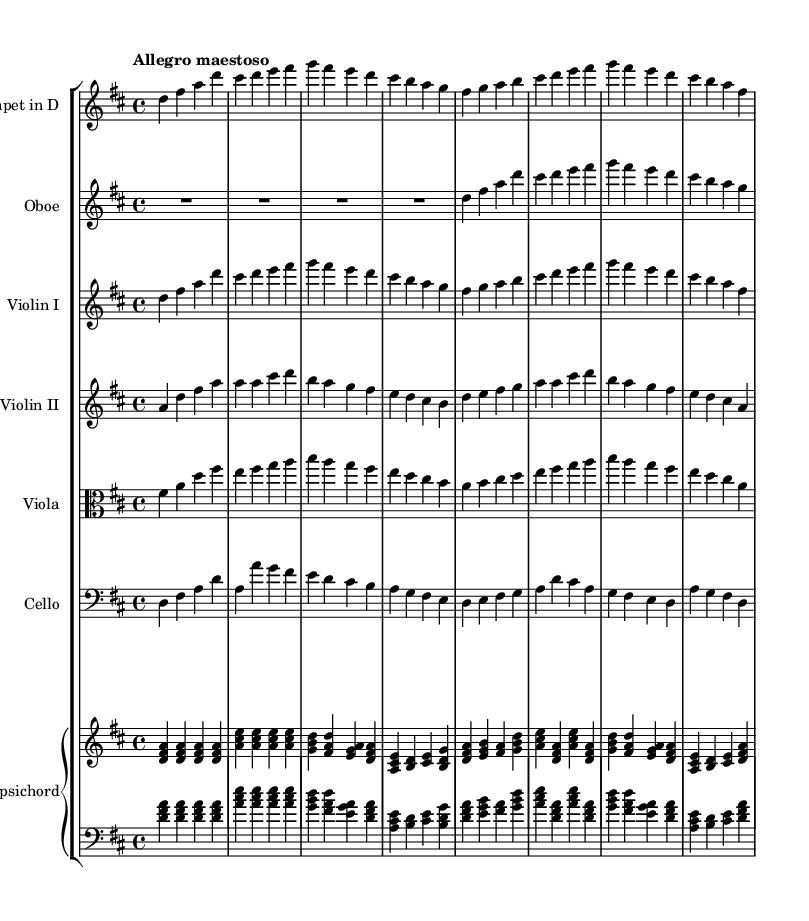What is the key signature of this music? The key signature is D major, which has two sharps (F# and C#). The presence of these sharps indicates that the music is composed in D major.
Answer: D major What is the time signature of this music? The time signature indicated is 4/4, meaning there are four beats in each measure, and the quarter note receives one beat. This can be identified at the beginning of the staff where the time signature is displayed.
Answer: 4/4 What is the tempo marking for this piece? The tempo marking is "Allegro maestoso," which denotes a fast and majestic tempo. This is stated at the beginning of the score.
Answer: Allegro maestoso How many instruments are included in this composition? The score features six different instruments: trumpet in D, oboe, violin I, violin II, viola, and cello, along with a harpsichord that serves as the continuo. This information can be seen in the staff groupings at the start of the score.
Answer: Six Which instrument plays the highest pitch in this arrangement? The trumpet in D generally plays the highest pitch throughout the piece, and its staff is positioned at the top of the score, indicating its role as a high melody voice.
Answer: Trumpet in D What is the interval between the lowest and highest note in the cello part? By analyzing the cello's part, the lowest note is D in the bass clef, while the highest note is A in the treble clef. The interval is a perfect fifth, which can be calculated by counting the notes from D to A.
Answer: Perfect fifth 